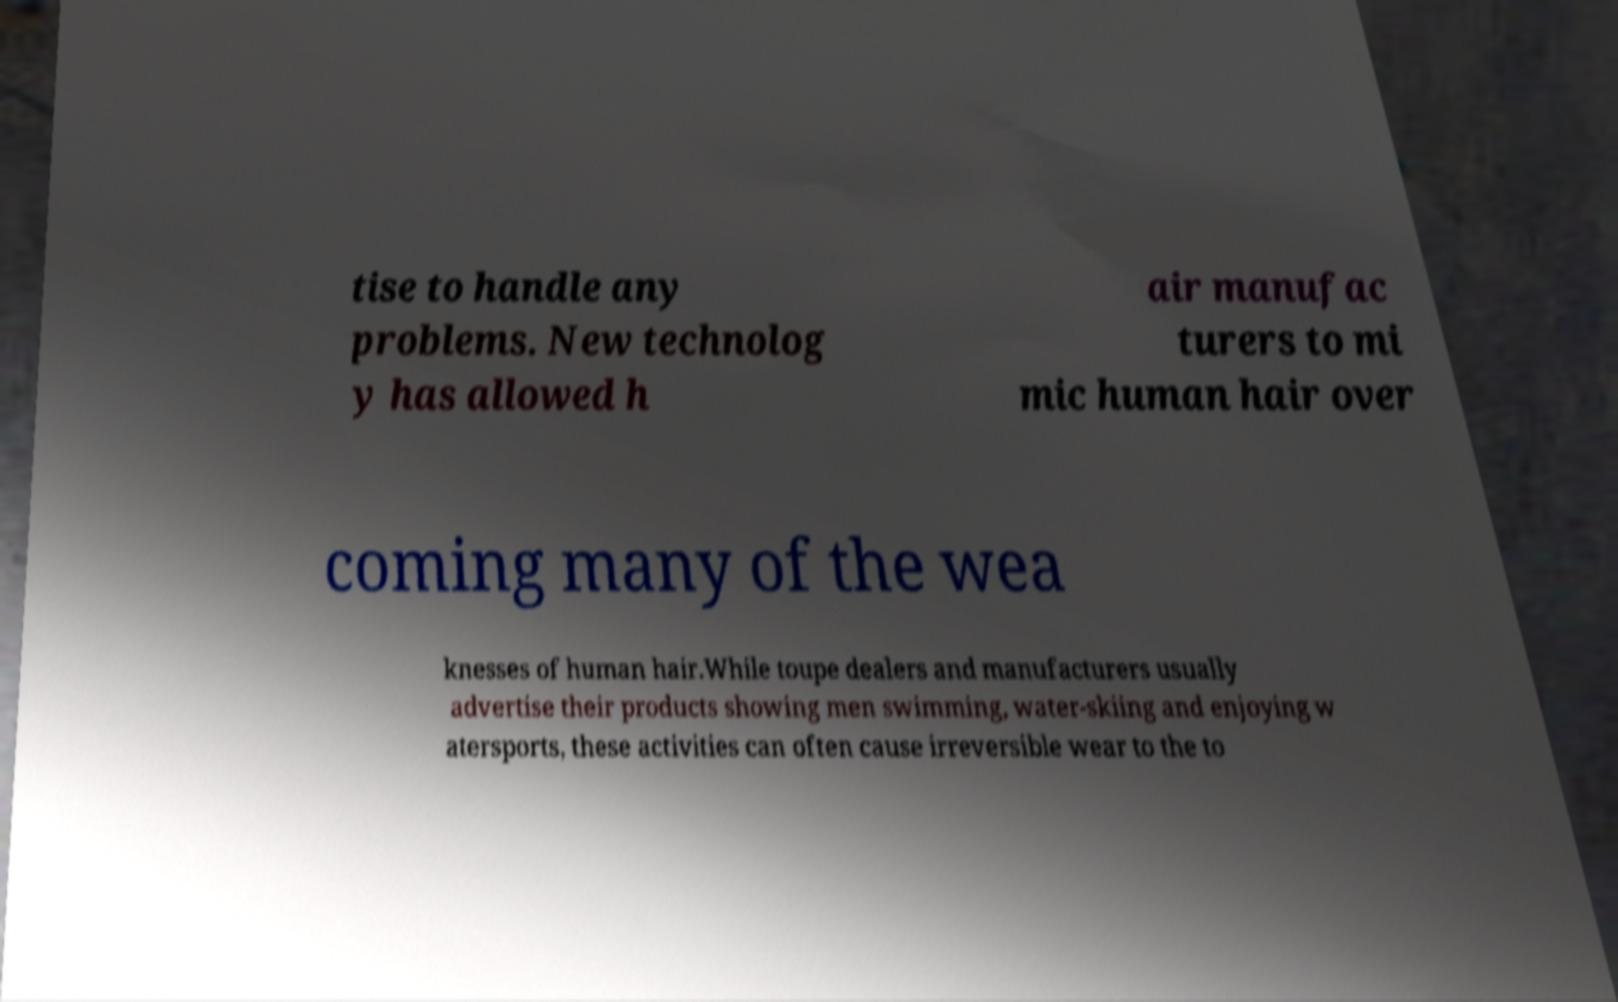Could you assist in decoding the text presented in this image and type it out clearly? tise to handle any problems. New technolog y has allowed h air manufac turers to mi mic human hair over coming many of the wea knesses of human hair.While toupe dealers and manufacturers usually advertise their products showing men swimming, water-skiing and enjoying w atersports, these activities can often cause irreversible wear to the to 